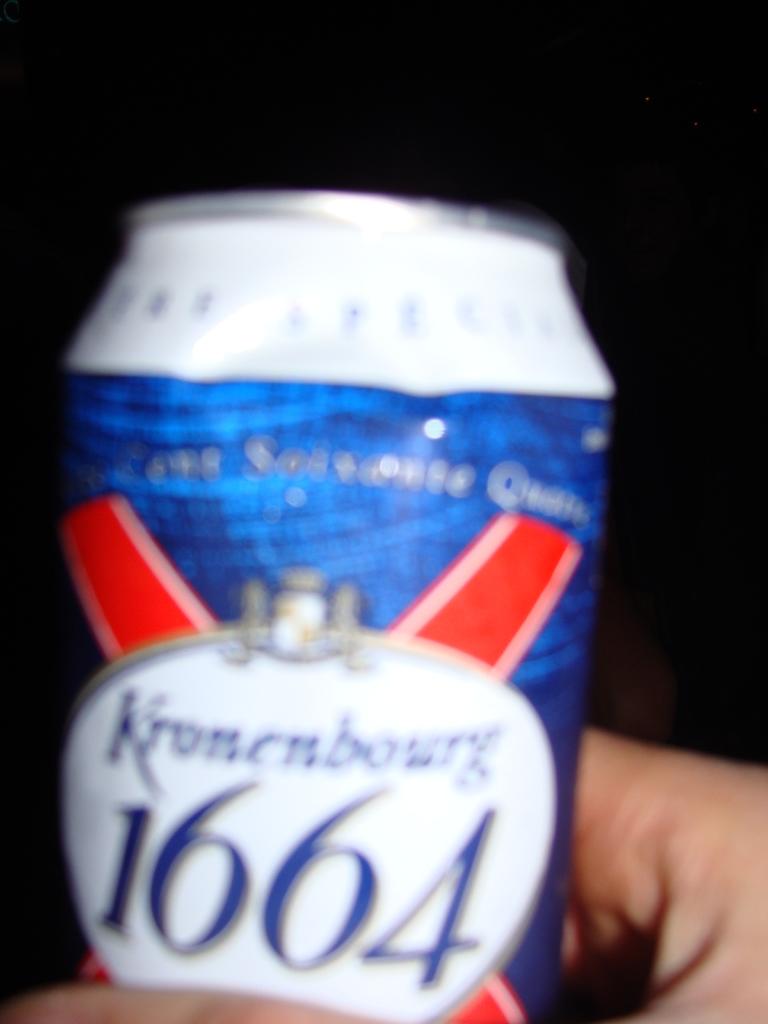What year is on the can?
Offer a very short reply. 1664. What brand of beer is this?
Ensure brevity in your answer.  Kronenbourg. 